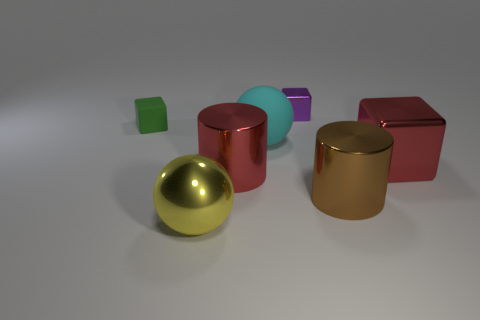Subtract all red cubes. How many cubes are left? 2 Add 1 small brown things. How many objects exist? 8 Subtract all red blocks. How many blocks are left? 2 Subtract all spheres. How many objects are left? 5 Subtract all large red things. Subtract all gray rubber things. How many objects are left? 5 Add 2 tiny cubes. How many tiny cubes are left? 4 Add 3 tiny rubber objects. How many tiny rubber objects exist? 4 Subtract 0 cyan blocks. How many objects are left? 7 Subtract 1 spheres. How many spheres are left? 1 Subtract all purple cubes. Subtract all yellow spheres. How many cubes are left? 2 